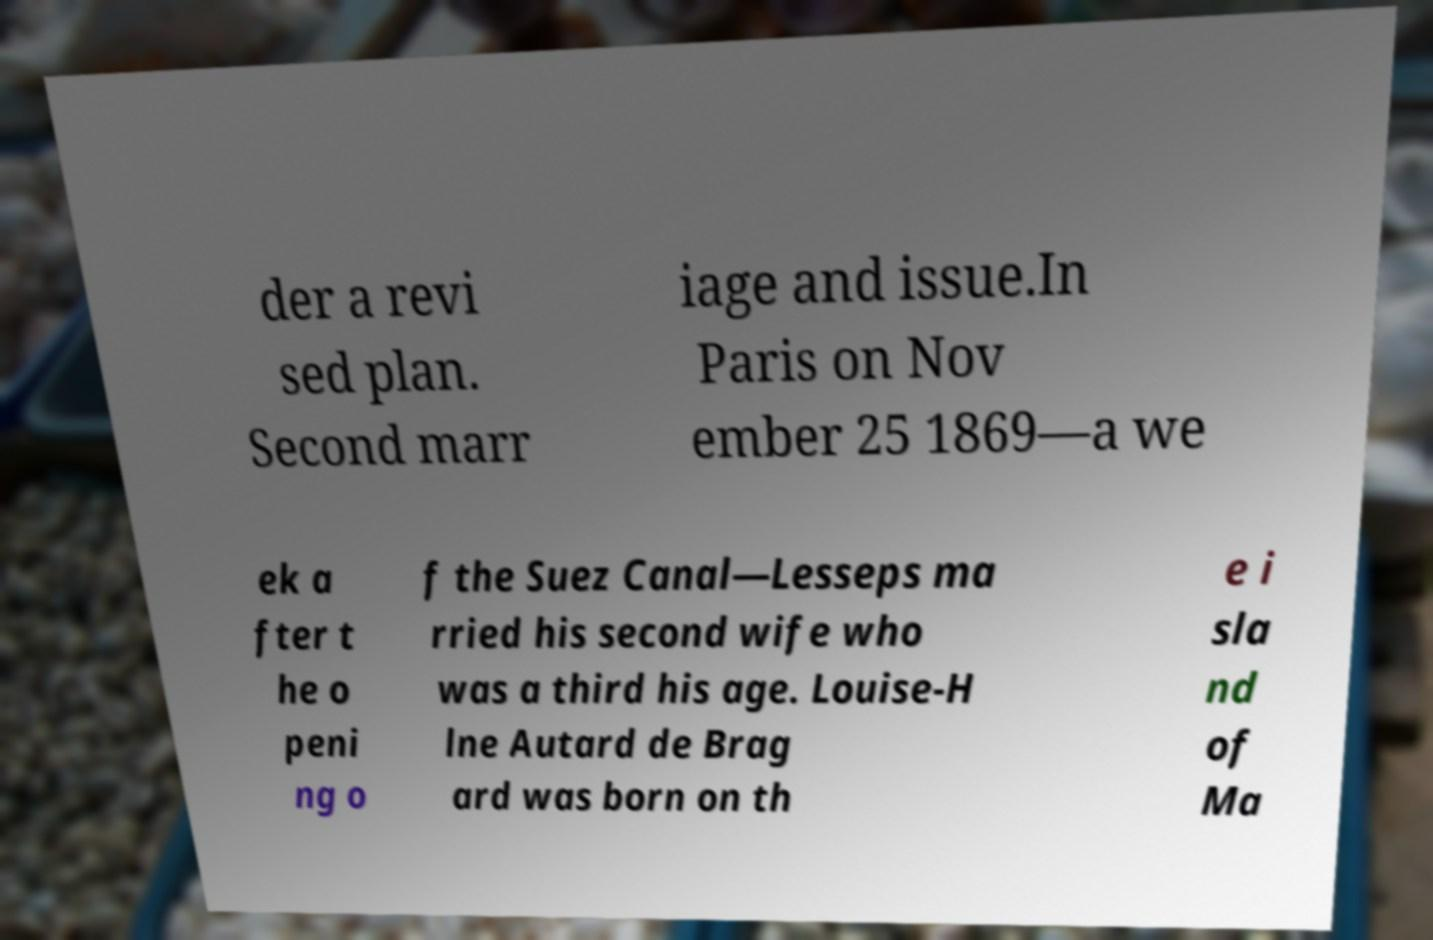Please read and relay the text visible in this image. What does it say? der a revi sed plan. Second marr iage and issue.In Paris on Nov ember 25 1869—a we ek a fter t he o peni ng o f the Suez Canal—Lesseps ma rried his second wife who was a third his age. Louise-H lne Autard de Brag ard was born on th e i sla nd of Ma 